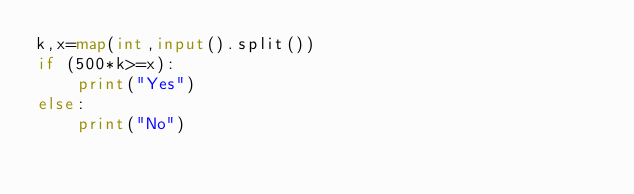Convert code to text. <code><loc_0><loc_0><loc_500><loc_500><_Python_>k,x=map(int,input().split())
if (500*k>=x):
    print("Yes")
else:
    print("No")
    
</code> 